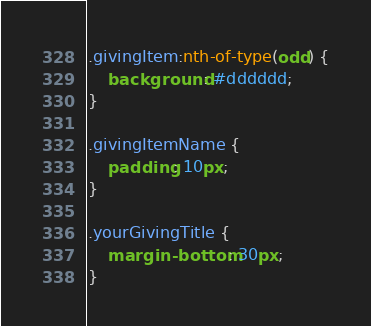Convert code to text. <code><loc_0><loc_0><loc_500><loc_500><_CSS_>.givingItem:nth-of-type(odd) {
    background: #dddddd;
}

.givingItemName {
    padding: 10px;
}

.yourGivingTitle {
    margin-bottom: 30px;
}


</code> 